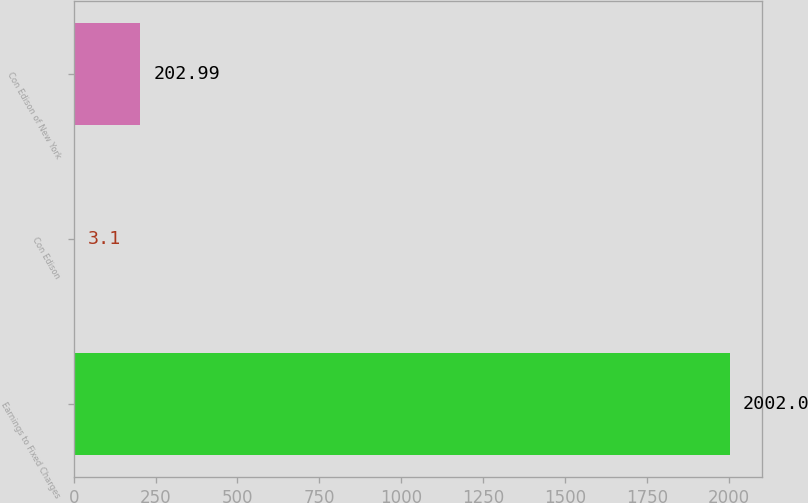Convert chart. <chart><loc_0><loc_0><loc_500><loc_500><bar_chart><fcel>Earnings to Fixed Charges<fcel>Con Edison<fcel>Con Edison of New York<nl><fcel>2002<fcel>3.1<fcel>202.99<nl></chart> 